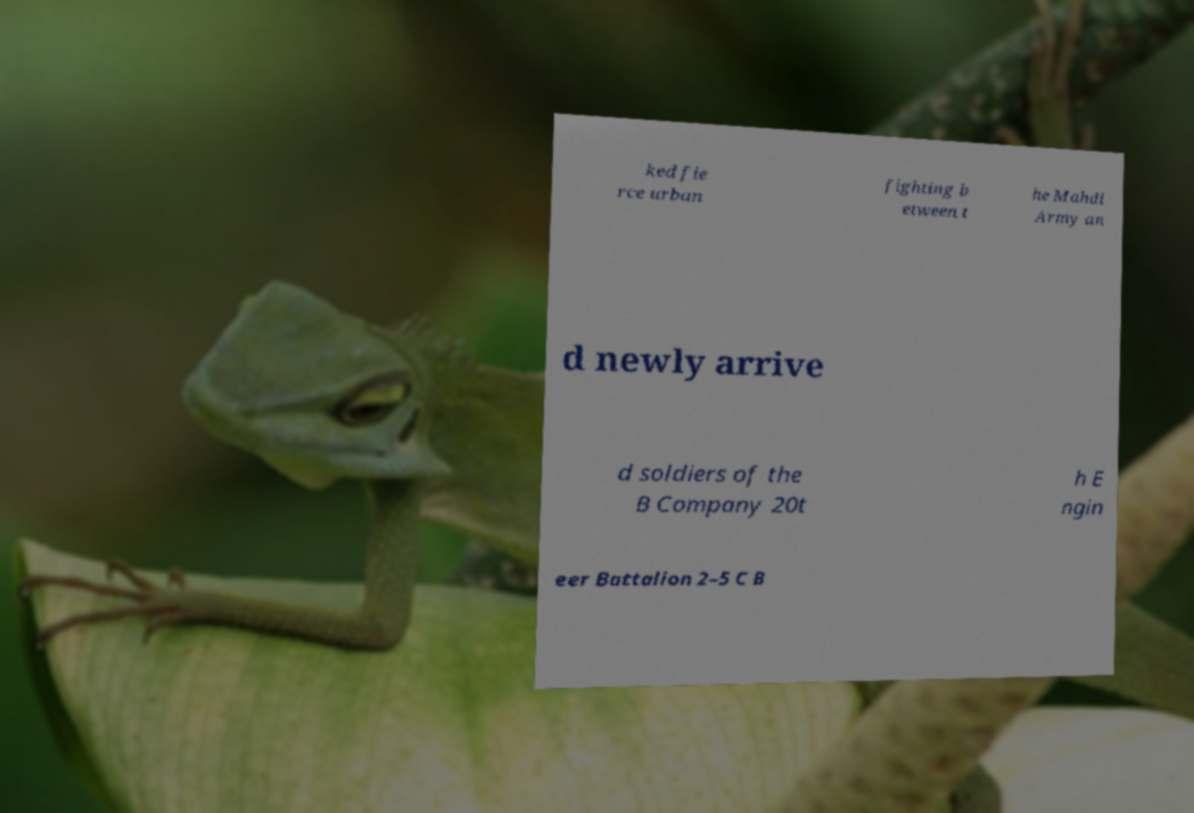Can you read and provide the text displayed in the image?This photo seems to have some interesting text. Can you extract and type it out for me? ked fie rce urban fighting b etween t he Mahdi Army an d newly arrive d soldiers of the B Company 20t h E ngin eer Battalion 2–5 C B 